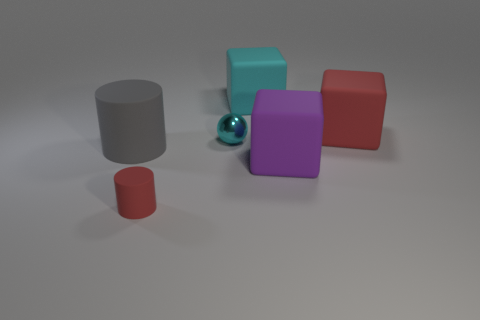Describe the positioning of the objects in relation to each other. The blue sphere is in the foreground, slightly to the left. The small red cylinder is to the left and in front of the sphere. Behind the small red cylinder is a red cube followed by a large gray cylinder. Further to the right, there is a teal cube with a purple cube behind it. 